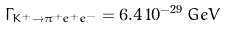<formula> <loc_0><loc_0><loc_500><loc_500>\Gamma _ { K ^ { + } \rightarrow \pi ^ { + } e ^ { + } e ^ { - } } = 6 . 4 \, 1 0 ^ { - 2 9 } \, G e V</formula> 